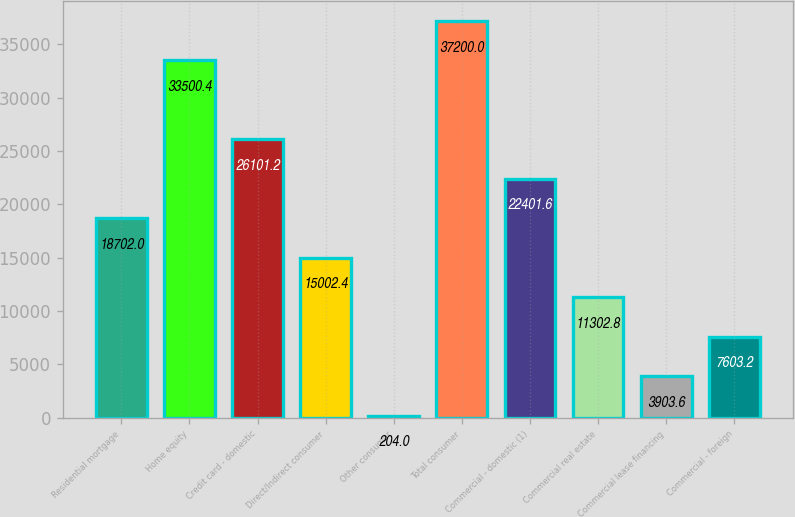Convert chart to OTSL. <chart><loc_0><loc_0><loc_500><loc_500><bar_chart><fcel>Residential mortgage<fcel>Home equity<fcel>Credit card - domestic<fcel>Direct/Indirect consumer<fcel>Other consumer<fcel>Total consumer<fcel>Commercial - domestic (1)<fcel>Commercial real estate<fcel>Commercial lease financing<fcel>Commercial - foreign<nl><fcel>18702<fcel>33500.4<fcel>26101.2<fcel>15002.4<fcel>204<fcel>37200<fcel>22401.6<fcel>11302.8<fcel>3903.6<fcel>7603.2<nl></chart> 